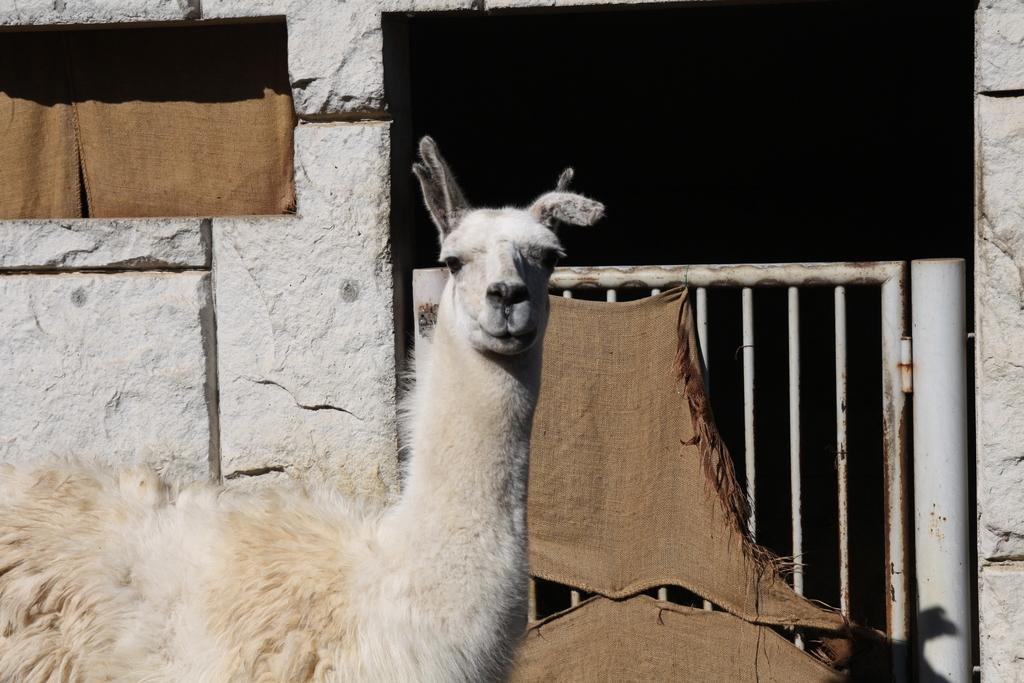What type of animal is present in the image? There is an animal in the image, but the specific type cannot be determined from the provided facts. What is the animal doing in the image? The animal is looking at someone in the image. What can be seen on the right side of the image? There is a gate on the right side of the image. What type of celery is the animal holding in the image? There is no celery present in the image, and the animal is not holding anything. 